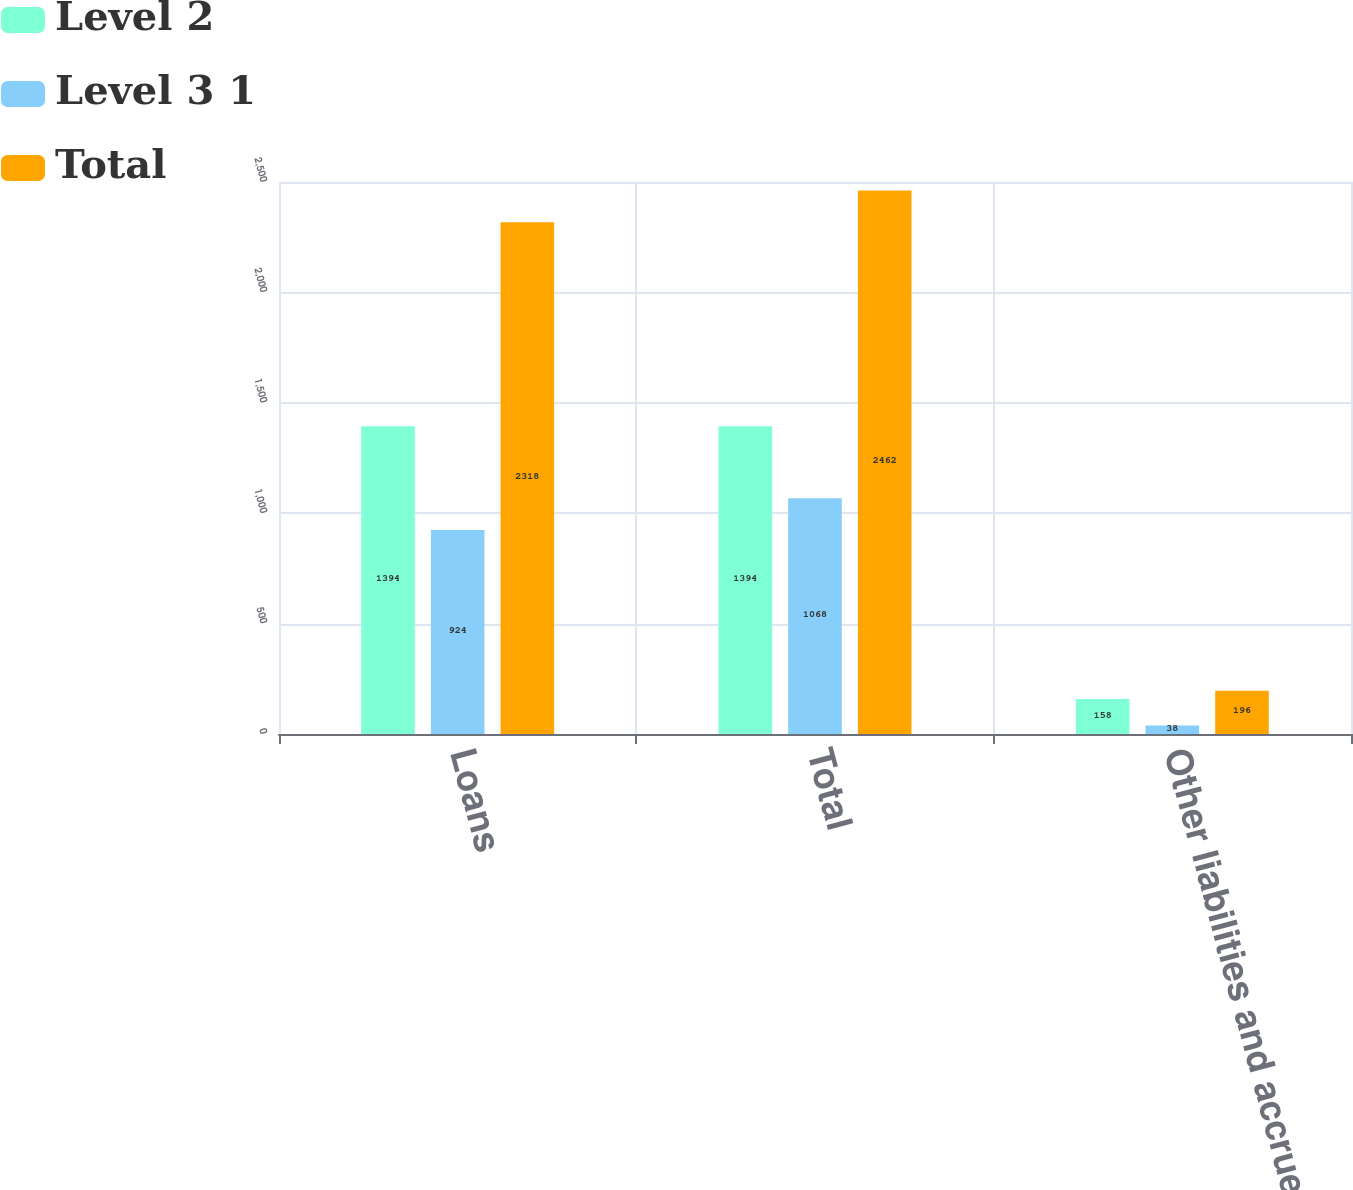<chart> <loc_0><loc_0><loc_500><loc_500><stacked_bar_chart><ecel><fcel>Loans<fcel>Total<fcel>Other liabilities and accrued<nl><fcel>Level 2<fcel>1394<fcel>1394<fcel>158<nl><fcel>Level 3 1<fcel>924<fcel>1068<fcel>38<nl><fcel>Total<fcel>2318<fcel>2462<fcel>196<nl></chart> 